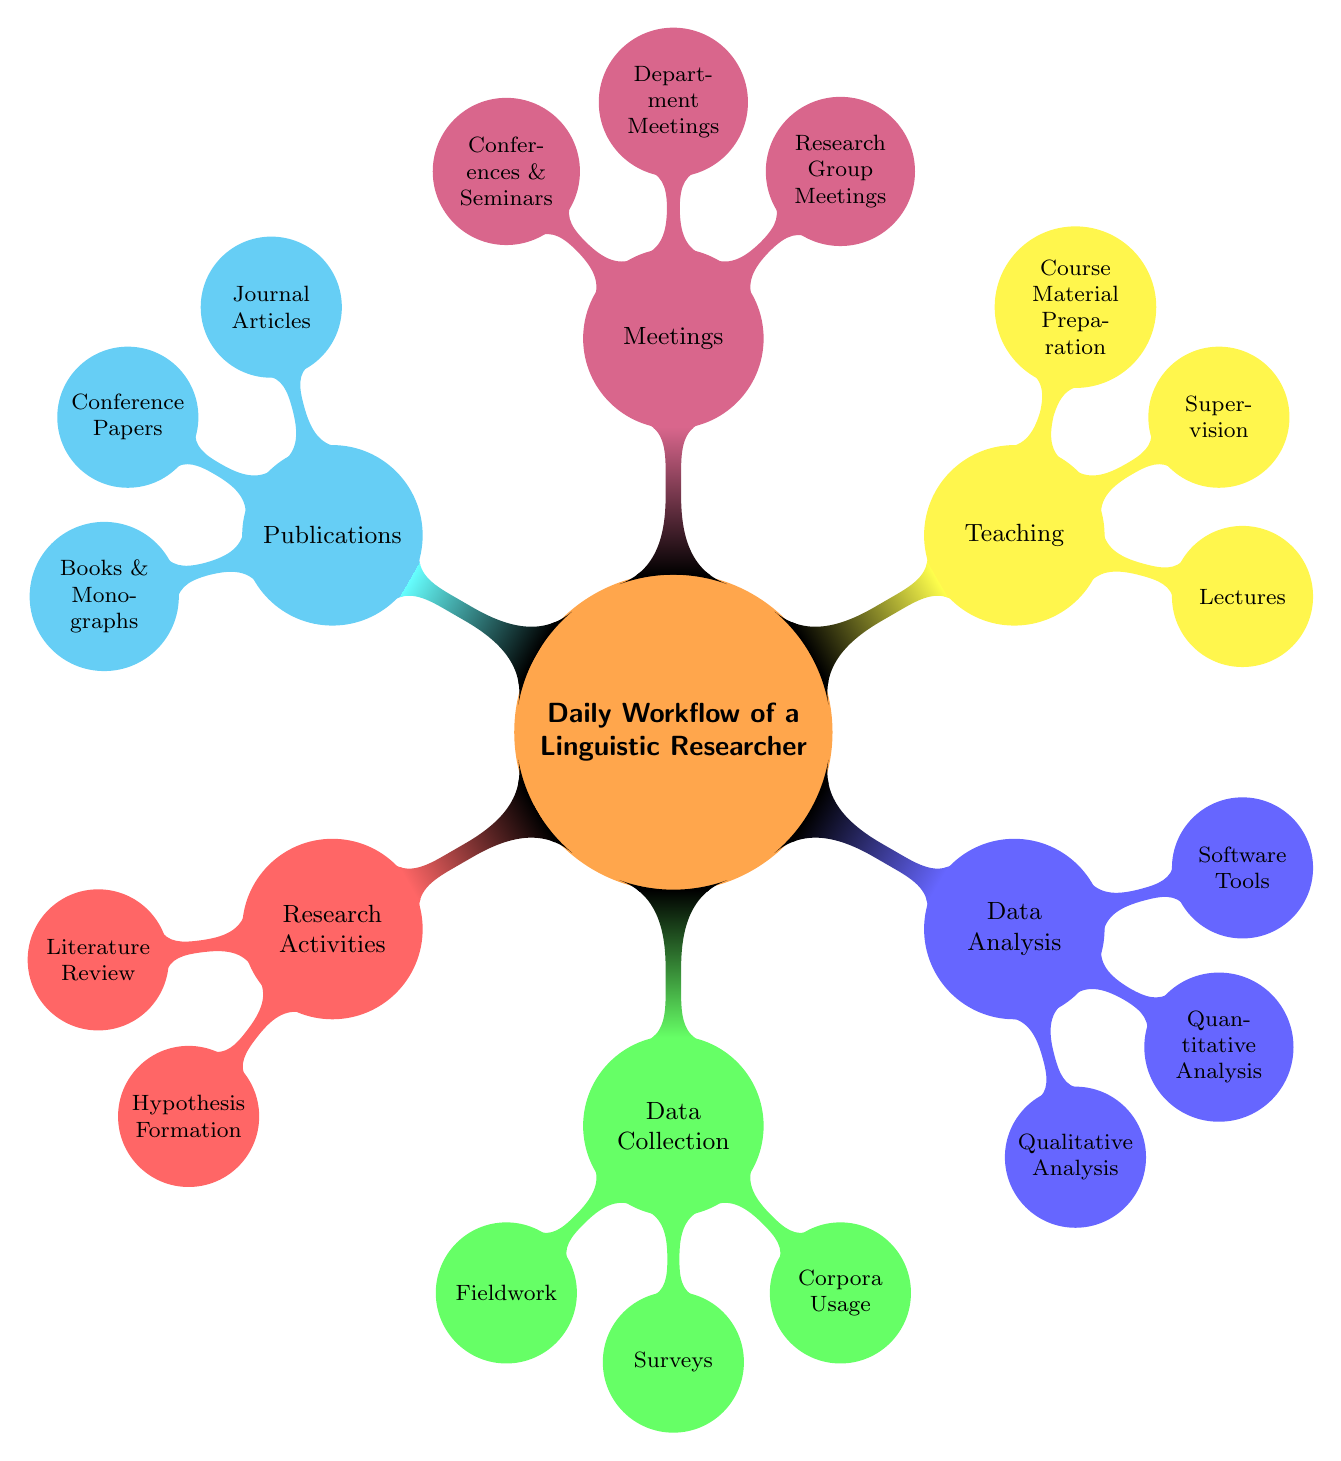What is the main focus of the mind map? The main focus of the mind map is indicated by the central node titled "Daily Workflow of a Linguistic Researcher." This node represents the overall theme that organizes the subsequent sub-nodes.
Answer: Daily Workflow of a Linguistic Researcher How many main categories are present in the diagram? By counting the main nodes branching out from the central node, we see there are a total of six main categories: Research Activities, Data Collection, Data Analysis, Teaching, Meetings, and Publications.
Answer: Six Which node contains the method for gathering quantitative data? The node that contains the method for gathering quantitative data is "Surveys" under the "Data Collection" category, as it specifically mentions distributing questionnaires to collect such data.
Answer: Surveys What are the two types of analysis mentioned in the "Data Analysis" node? The "Data Analysis" node specifies "Qualitative Analysis" and "Quantitative Analysis" as the two types of analysis, clearly laid out in the sub-nodes of that category.
Answer: Qualitative Analysis and Quantitative Analysis Which activity is associated with guiding students in their research? The activity associated with guiding students in their research is labeled "Supervision" under the "Teaching" category, indicating that it involves overseeing students’ projects.
Answer: Supervision How are publications categorized in the diagram? Publications are categorized into three distinct areas: "Journal Articles," "Conference Papers," and "Books & Monographs," as shown in the relevant sub-nodes under the "Publications" category.
Answer: Journal Articles, Conference Papers, and Books & Monographs Which type of meetings focus on collaboration among researchers? The type of meetings that focus on collaboration among researchers is "Research Group Meetings," which is explicitly mentioned as a sub-node under the "Meetings" category.
Answer: Research Group Meetings What software tool is used for transcribing spoken language data? The software tool used for transcribing spoken language data mentioned in the diagram is "ELAN," which falls under the "Software Tools" sub-node in the "Data Analysis" category.
Answer: ELAN What is the purpose of collecting data through "Fieldwork"? The purpose of collecting data through "Fieldwork," as defined in the diagram, is to gather data from native speakers, which includes conducting interviews and recording speech samples.
Answer: Collecting data from native speakers 